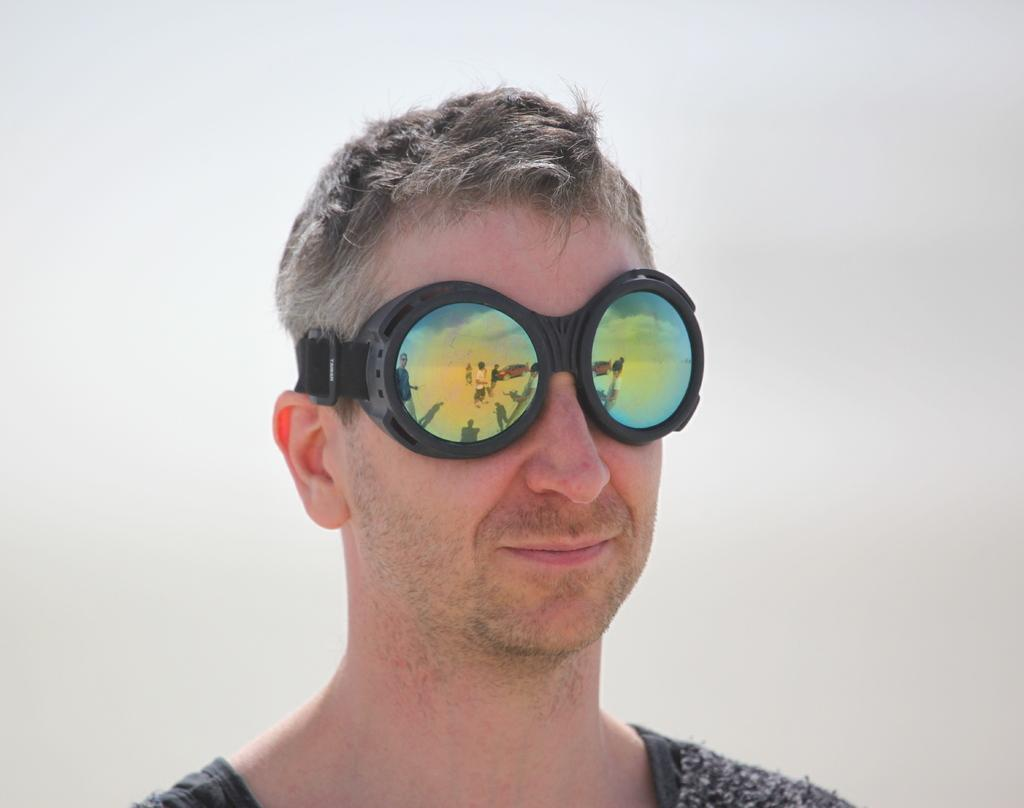What is the main subject of the image? There is a person in the image. What is the person wearing in the image? The person is wearing goggles. What type of silver is the person using to express their belief in the town? There is no silver or town mentioned in the image, and the person's beliefs are not depicted. 